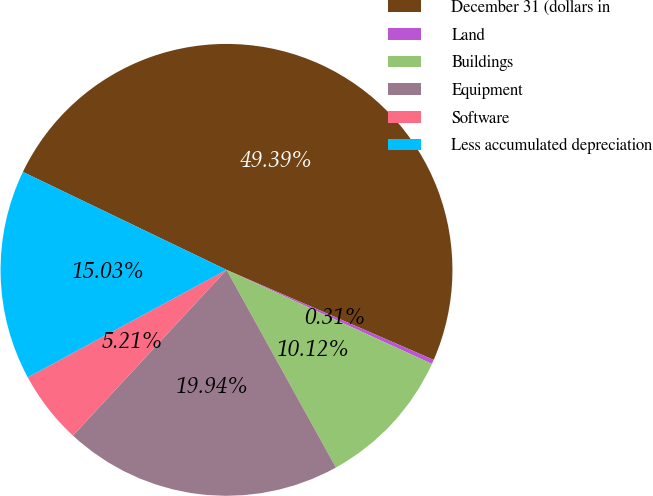<chart> <loc_0><loc_0><loc_500><loc_500><pie_chart><fcel>December 31 (dollars in<fcel>Land<fcel>Buildings<fcel>Equipment<fcel>Software<fcel>Less accumulated depreciation<nl><fcel>49.39%<fcel>0.31%<fcel>10.12%<fcel>19.94%<fcel>5.21%<fcel>15.03%<nl></chart> 